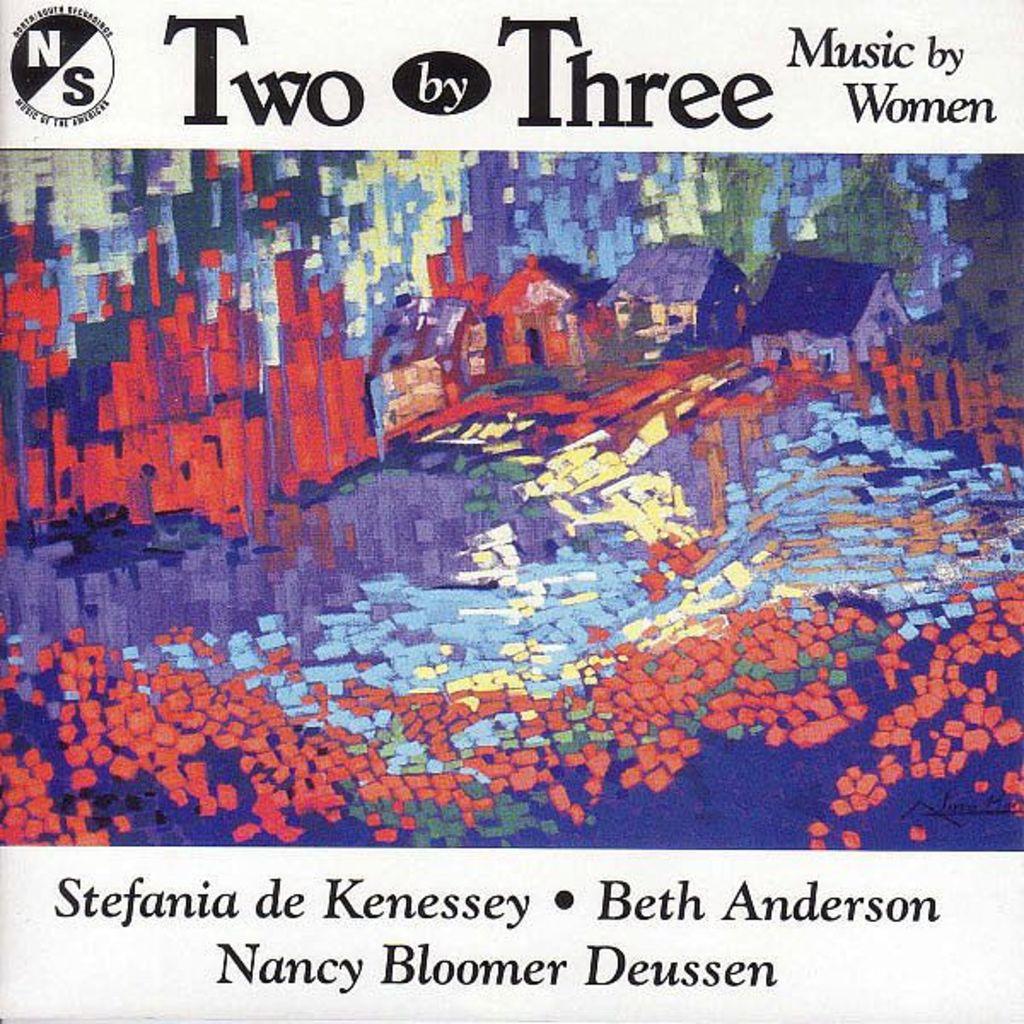What is the title of this work?
Your answer should be very brief. Two by three. What does the album say the music is by?
Keep it short and to the point. Women. 